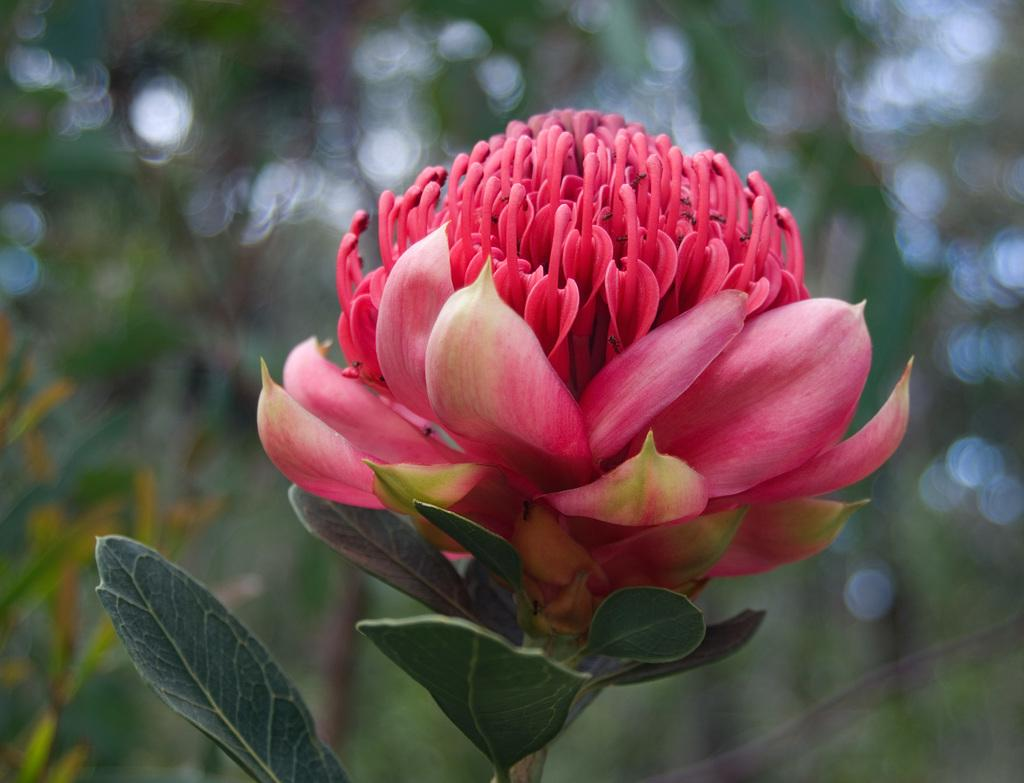What type of flower is in the image? There is a red flower in the image. What other parts of the flower can be seen besides the petals? The red flower has leaves. How would you describe the background of the image? The background of the image is blurred. What type of pancake is being served on the plate in the image? There is no plate or pancake visible in the image; it only features a red flower with leaves. Can you tell me how many seeds are present in the flower? The image does not provide enough detail to determine the number of seeds in the flower. 